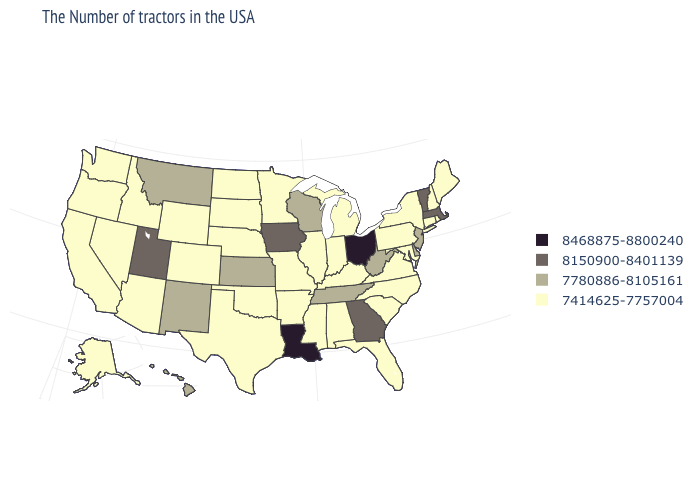Does North Dakota have a higher value than Alaska?
Concise answer only. No. What is the value of New Mexico?
Short answer required. 7780886-8105161. Name the states that have a value in the range 7780886-8105161?
Give a very brief answer. New Jersey, Delaware, West Virginia, Tennessee, Wisconsin, Kansas, New Mexico, Montana, Hawaii. Does Oklahoma have the lowest value in the USA?
Answer briefly. Yes. Among the states that border Missouri , which have the lowest value?
Be succinct. Kentucky, Illinois, Arkansas, Nebraska, Oklahoma. Does New Hampshire have the lowest value in the USA?
Write a very short answer. Yes. Which states have the lowest value in the MidWest?
Keep it brief. Michigan, Indiana, Illinois, Missouri, Minnesota, Nebraska, South Dakota, North Dakota. Among the states that border Ohio , does West Virginia have the highest value?
Short answer required. Yes. Name the states that have a value in the range 7780886-8105161?
Short answer required. New Jersey, Delaware, West Virginia, Tennessee, Wisconsin, Kansas, New Mexico, Montana, Hawaii. What is the lowest value in the MidWest?
Give a very brief answer. 7414625-7757004. Which states have the lowest value in the USA?
Be succinct. Maine, Rhode Island, New Hampshire, Connecticut, New York, Maryland, Pennsylvania, Virginia, North Carolina, South Carolina, Florida, Michigan, Kentucky, Indiana, Alabama, Illinois, Mississippi, Missouri, Arkansas, Minnesota, Nebraska, Oklahoma, Texas, South Dakota, North Dakota, Wyoming, Colorado, Arizona, Idaho, Nevada, California, Washington, Oregon, Alaska. Name the states that have a value in the range 8468875-8800240?
Answer briefly. Ohio, Louisiana. What is the highest value in states that border North Carolina?
Be succinct. 8150900-8401139. Name the states that have a value in the range 7414625-7757004?
Concise answer only. Maine, Rhode Island, New Hampshire, Connecticut, New York, Maryland, Pennsylvania, Virginia, North Carolina, South Carolina, Florida, Michigan, Kentucky, Indiana, Alabama, Illinois, Mississippi, Missouri, Arkansas, Minnesota, Nebraska, Oklahoma, Texas, South Dakota, North Dakota, Wyoming, Colorado, Arizona, Idaho, Nevada, California, Washington, Oregon, Alaska. What is the lowest value in the West?
Be succinct. 7414625-7757004. 